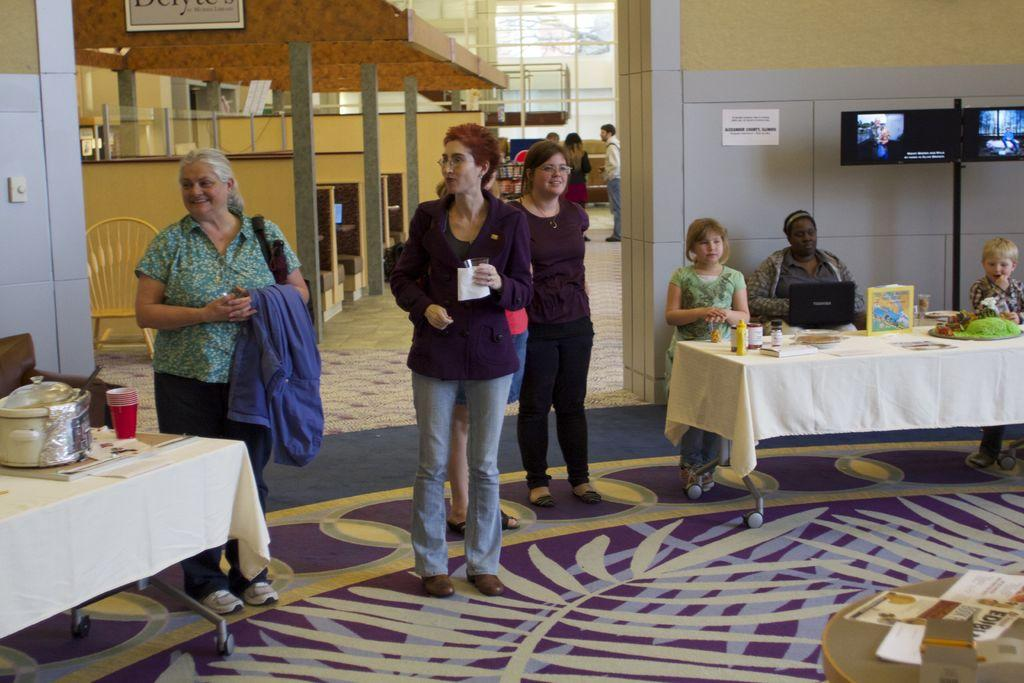What are the people in the image doing? There are people standing and sitting on chairs in the image. What object is on the table in the image? There is a laptop on the table in the image. What else can be found on the table in the image? There are food items in a vessel on the table in the image. What type of roof can be seen in the image? There is no roof visible in the image. What flavor of food is being served in the vessel on the table? The image does not provide information about the flavor of the food in the vessel. 